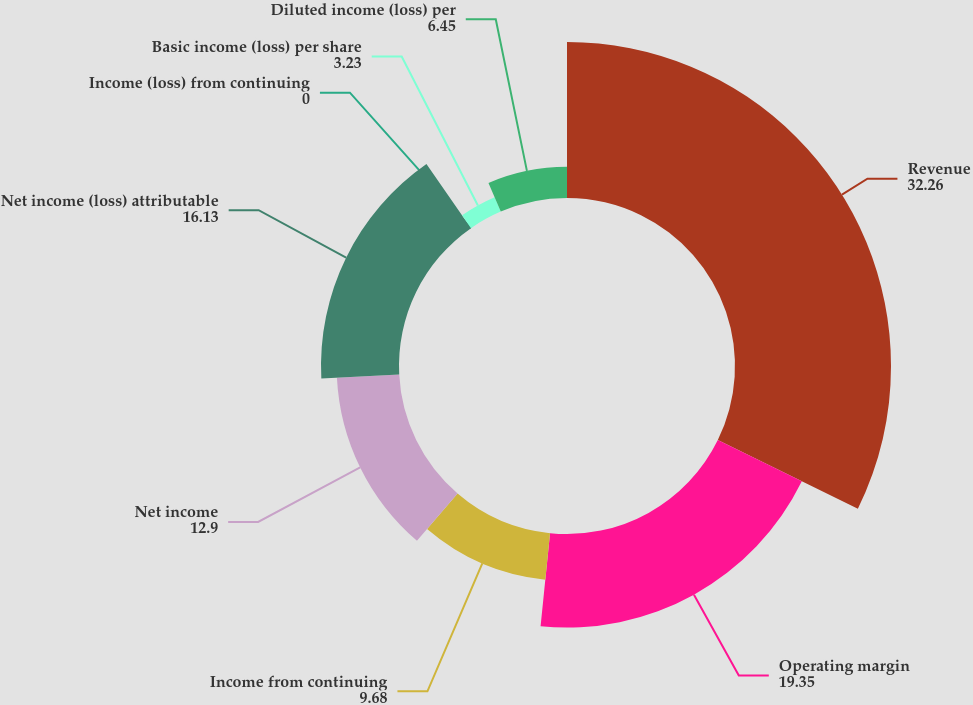Convert chart to OTSL. <chart><loc_0><loc_0><loc_500><loc_500><pie_chart><fcel>Revenue<fcel>Operating margin<fcel>Income from continuing<fcel>Net income<fcel>Net income (loss) attributable<fcel>Income (loss) from continuing<fcel>Basic income (loss) per share<fcel>Diluted income (loss) per<nl><fcel>32.26%<fcel>19.35%<fcel>9.68%<fcel>12.9%<fcel>16.13%<fcel>0.0%<fcel>3.23%<fcel>6.45%<nl></chart> 